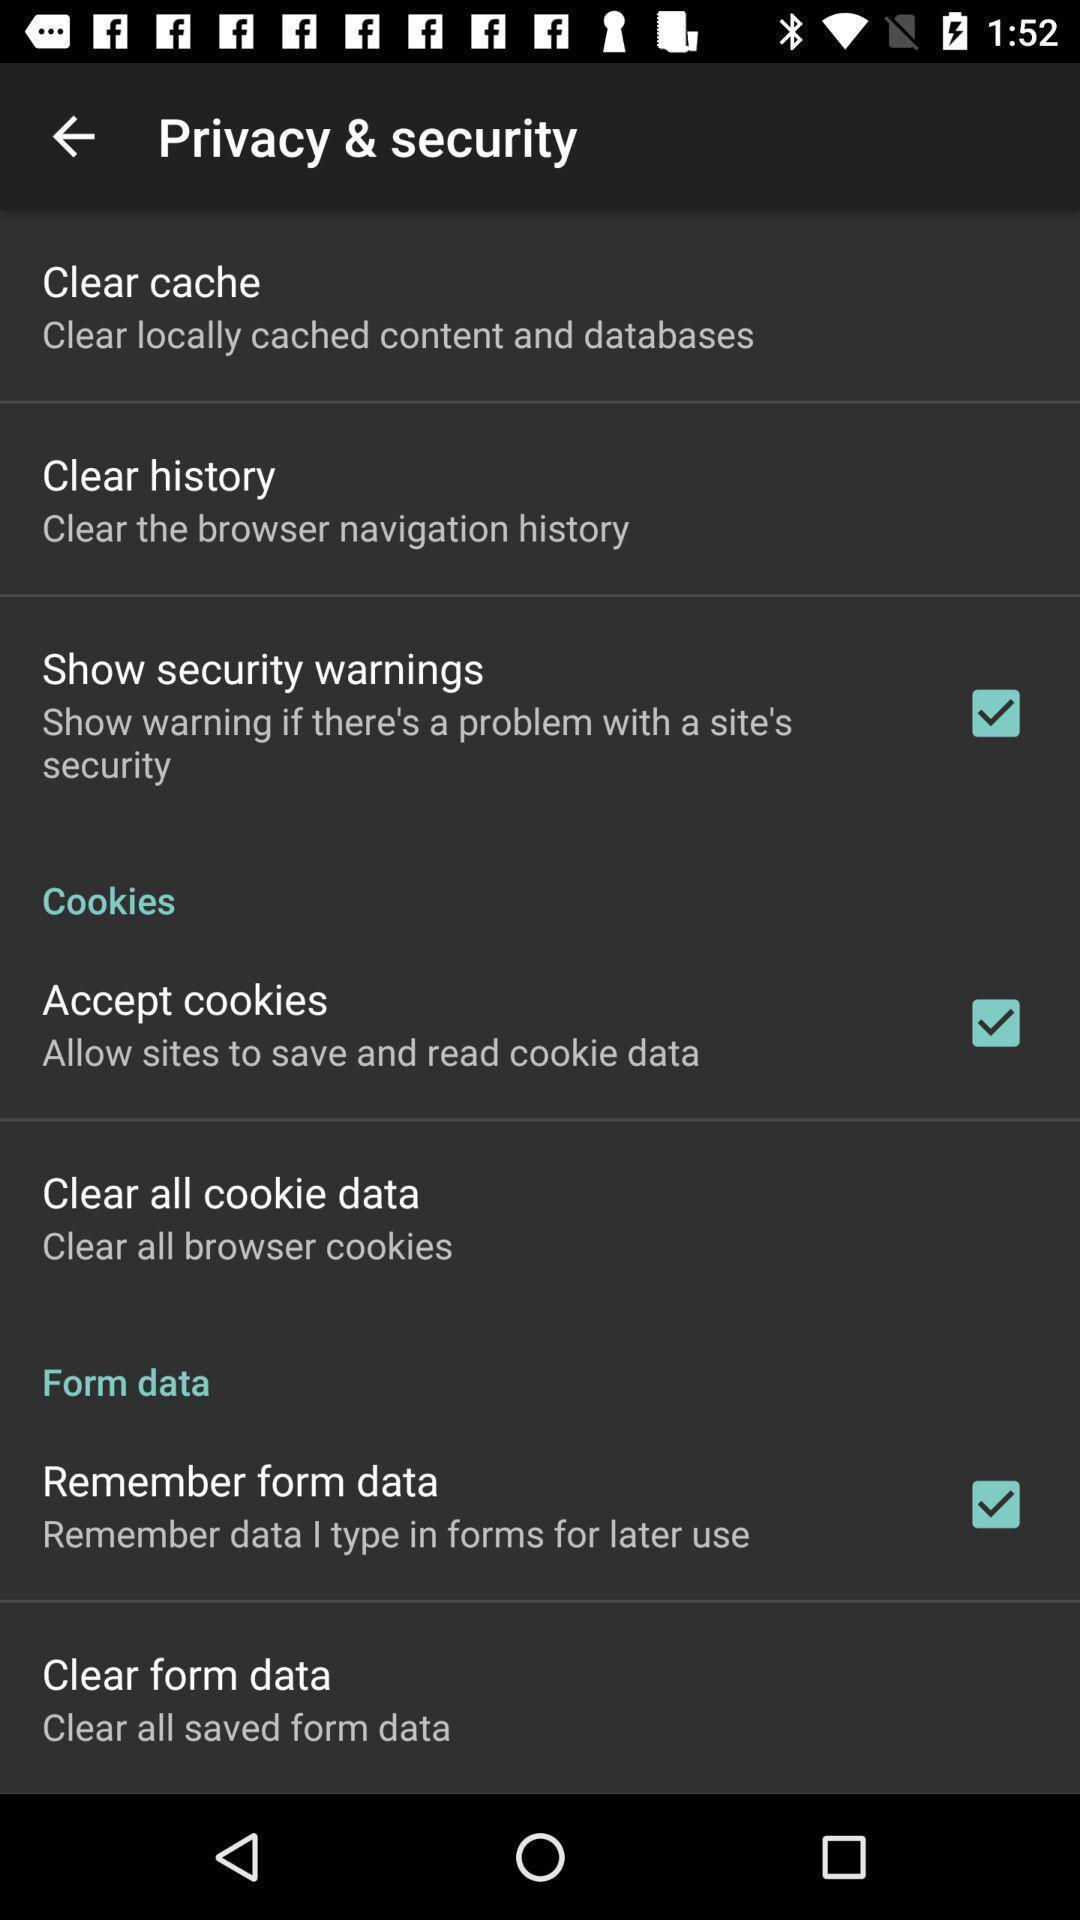Please provide a description for this image. Page displaying privacy security settings. 